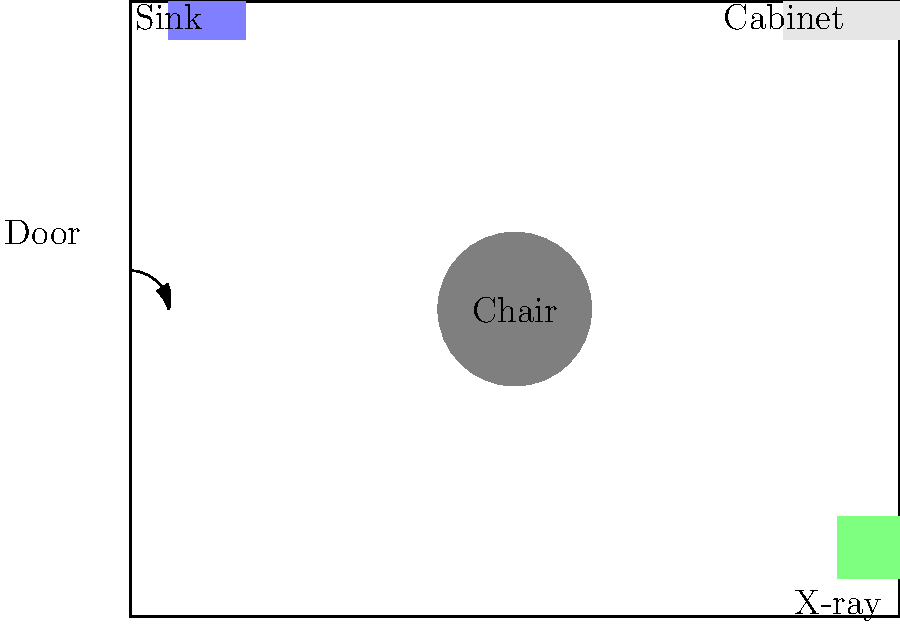Based on the given dental office floor plan, which piece of equipment should be relocated to improve workflow efficiency and patient comfort? Explain your reasoning. To determine which piece of equipment should be relocated, we need to consider the following factors:

1. Patient flow: The dental chair is centrally located, which is good for access.
2. Hygiene: The sink is near the entrance, allowing for hand washing upon entry.
3. Storage: The cabinet is positioned in the back, away from the main work area.
4. X-ray safety: The X-ray machine is isolated in a corner, which is good for radiation protection.

However, the current layout has one major issue:

5. X-ray accessibility: The X-ray machine is far from the dental chair, requiring patients to move across the room for imaging.

To improve workflow efficiency and patient comfort:

6. The X-ray machine should be moved closer to the dental chair.
7. A suitable new location would be the area between the chair and the sink, approximately at (25,60).
8. This relocation would minimize patient movement and improve the dentist's workflow.

The other equipment is well-placed:
9. The sink remains near the entrance for hygiene.
10. The cabinet stays in the back for storage without obstructing the work area.
11. The chair maintains its central position for easy access.
Answer: X-ray machine 